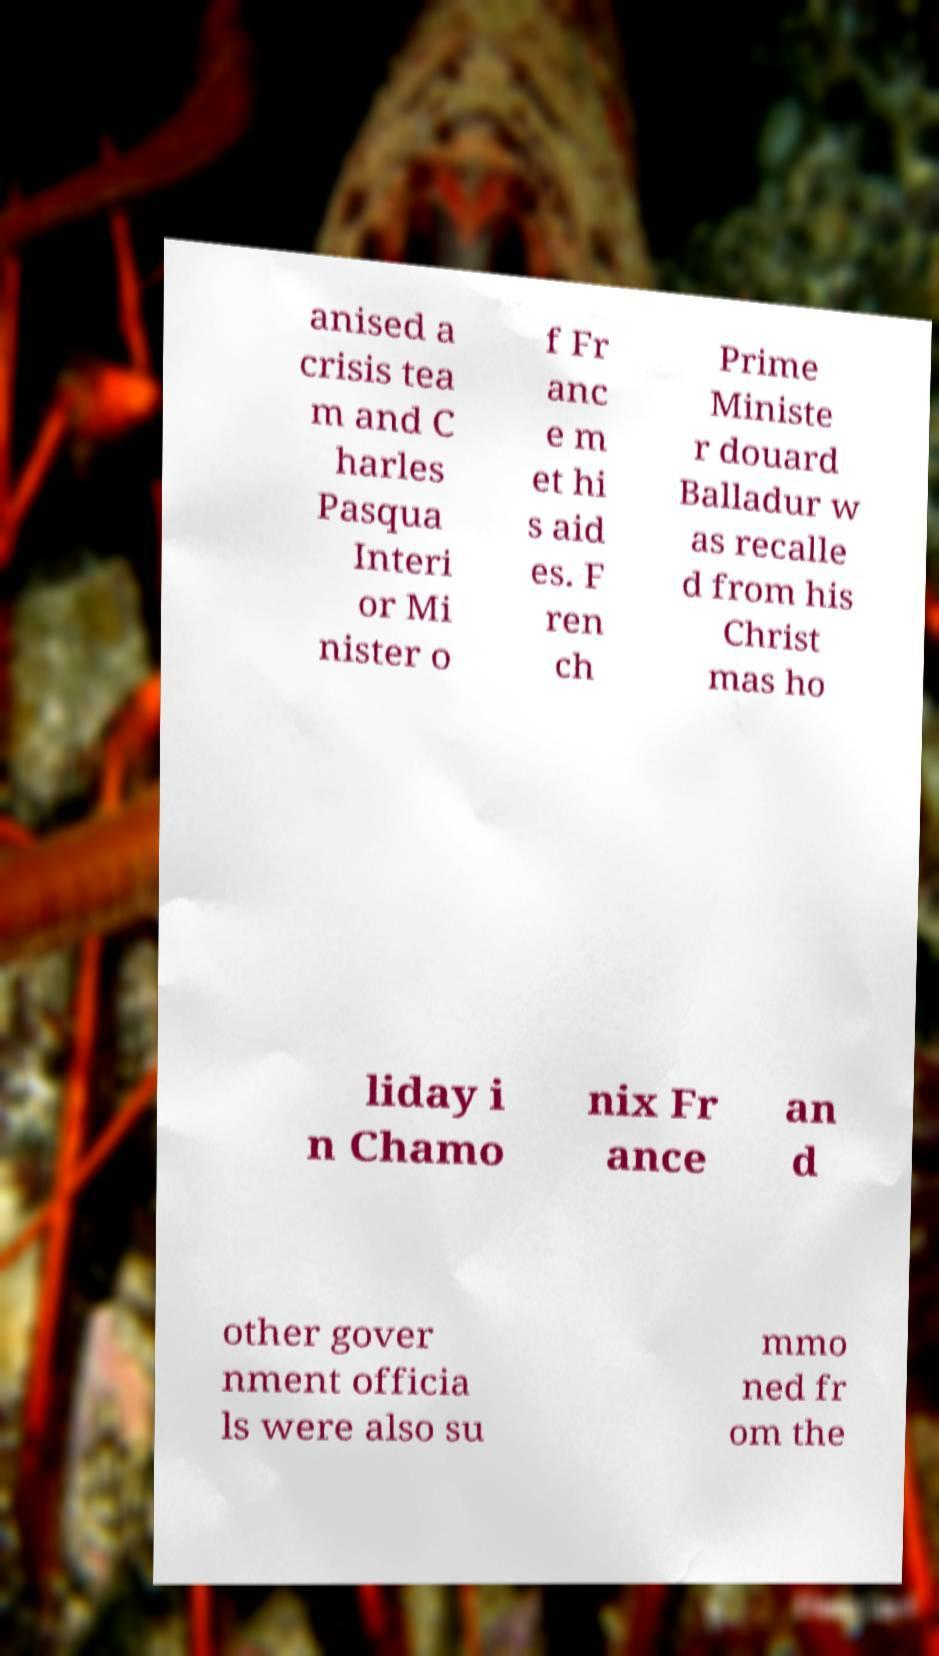I need the written content from this picture converted into text. Can you do that? anised a crisis tea m and C harles Pasqua Interi or Mi nister o f Fr anc e m et hi s aid es. F ren ch Prime Ministe r douard Balladur w as recalle d from his Christ mas ho liday i n Chamo nix Fr ance an d other gover nment officia ls were also su mmo ned fr om the 